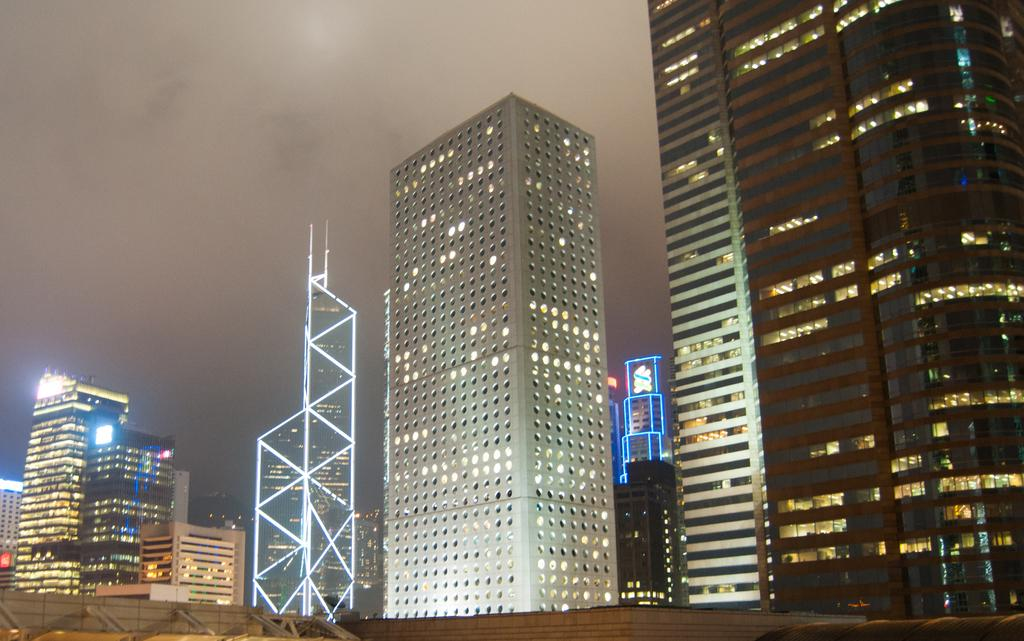What structures are located in the foreground of the image? There are buildings in the foreground of the image. What else can be seen in the foreground of the image besides the buildings? There are lights visible in the foreground of the image. What is visible at the top of the image? The sky is visible at the top of the image. What type of belief is being expressed by the rake in the image? There is no rake present in the image, and therefore no belief can be attributed to it. How many times does the person in the image sneeze? There is no person present in the image, and therefore no sneezing can be observed. 